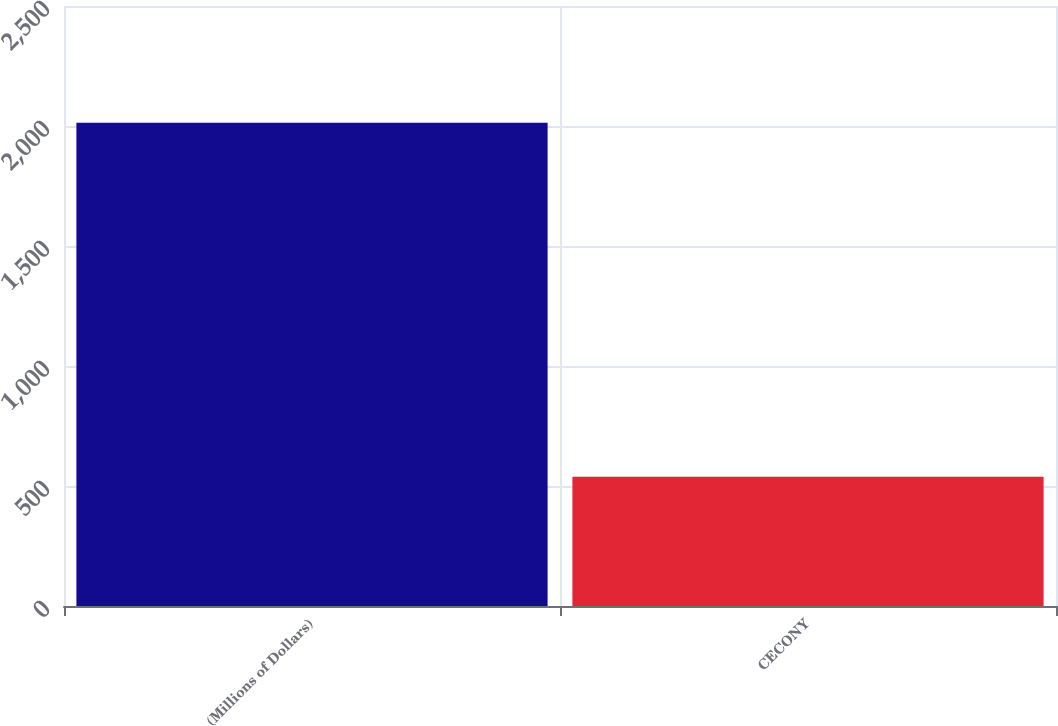Convert chart to OTSL. <chart><loc_0><loc_0><loc_500><loc_500><bar_chart><fcel>(Millions of Dollars)<fcel>CECONY<nl><fcel>2014<fcel>539<nl></chart> 